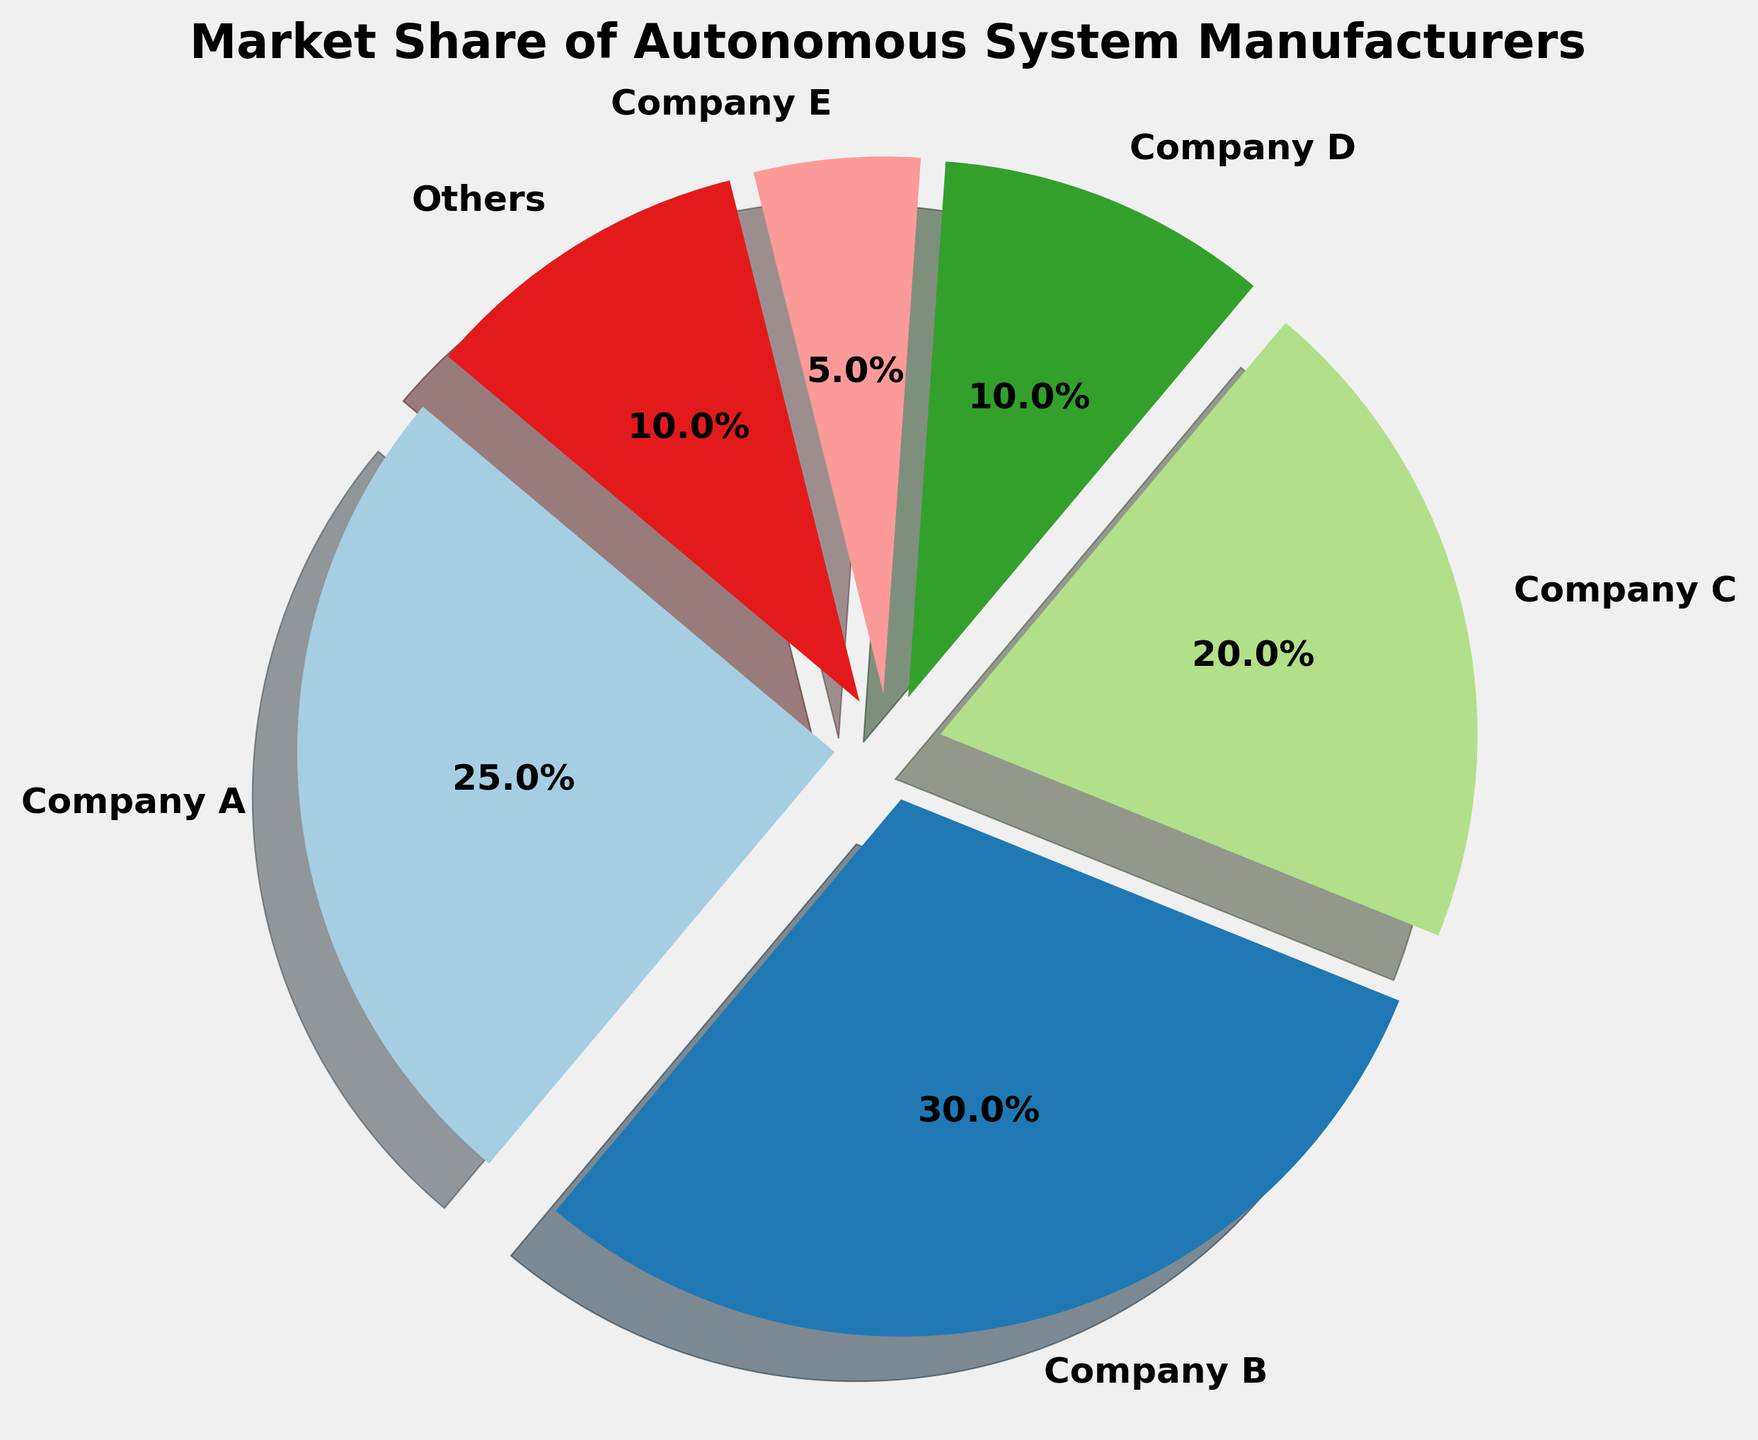What is the market share percentage of Company B? Observing the pie chart, we can identify the segment labeled 'Company B' and read off its corresponding market share percentage, which is displayed as a percentage value.
Answer: 30% Which company has the smallest market share? The pie chart has segments of varying sizes, and the smallest segment represents the company with the smallest market share. Upon inspection, the smallest segment belongs to Company E.
Answer: Company E What is the combined market share of Company A and Company C? To find the combined market share, add the market share percentages of Company A and Company C. Company A has 25% and Company C has 20%, so their combined market share is 25% + 20%.
Answer: 45% How much larger is the market share of Company B compared to Company D? To find the difference in market share between Company B and Company D, subtract the percentage of Company D from that of Company B. Company B has 30% and Company D has 10%, so 30% - 10% = 20%.
Answer: 20% What is the average market share of all companies except 'Others'? To find the average market share, add the market share percentages of all companies except 'Others' and divide by the number of these companies. The sum is 25% + 30% + 20% + 10% + 5% = 90%. There are 5 companies, so the average is 90% / 5.
Answer: 18% Which companies together constitute more than 50% of the market share? Analyze the segments and sum the percentages of the largest shares until the total exceeds 50%. Company B has 30%, and Company A has 25%, so together they add up to 55%.
Answer: Company A and Company B What is the proportion of the market share of 'Others' compared to Company C? To find the proportion, divide the market share percentage of 'Others' by that of Company C. 'Others' is at 10%, and Company C is at 20%, so the proportion is 10% / 20% = 0.5.
Answer: 0.5 What color represents the segment for Company D? Find the segment labeled 'Company D' in the pie chart and describe its visual color.
Answer: Gray (Please note: Verify the actual color based on the plot generated) How does the market share of the largest company compare to the sum of the two smallest companies? Identify the largest segment (Company B at 30%) and the two smallest segments (Company E at 5% and 'Others' at 10%). Sum the two smallest shares (5% + 10% = 15%) and then compare to the largest. Company B's 30% is double the combined 15% of the two smallest.
Answer: Double 